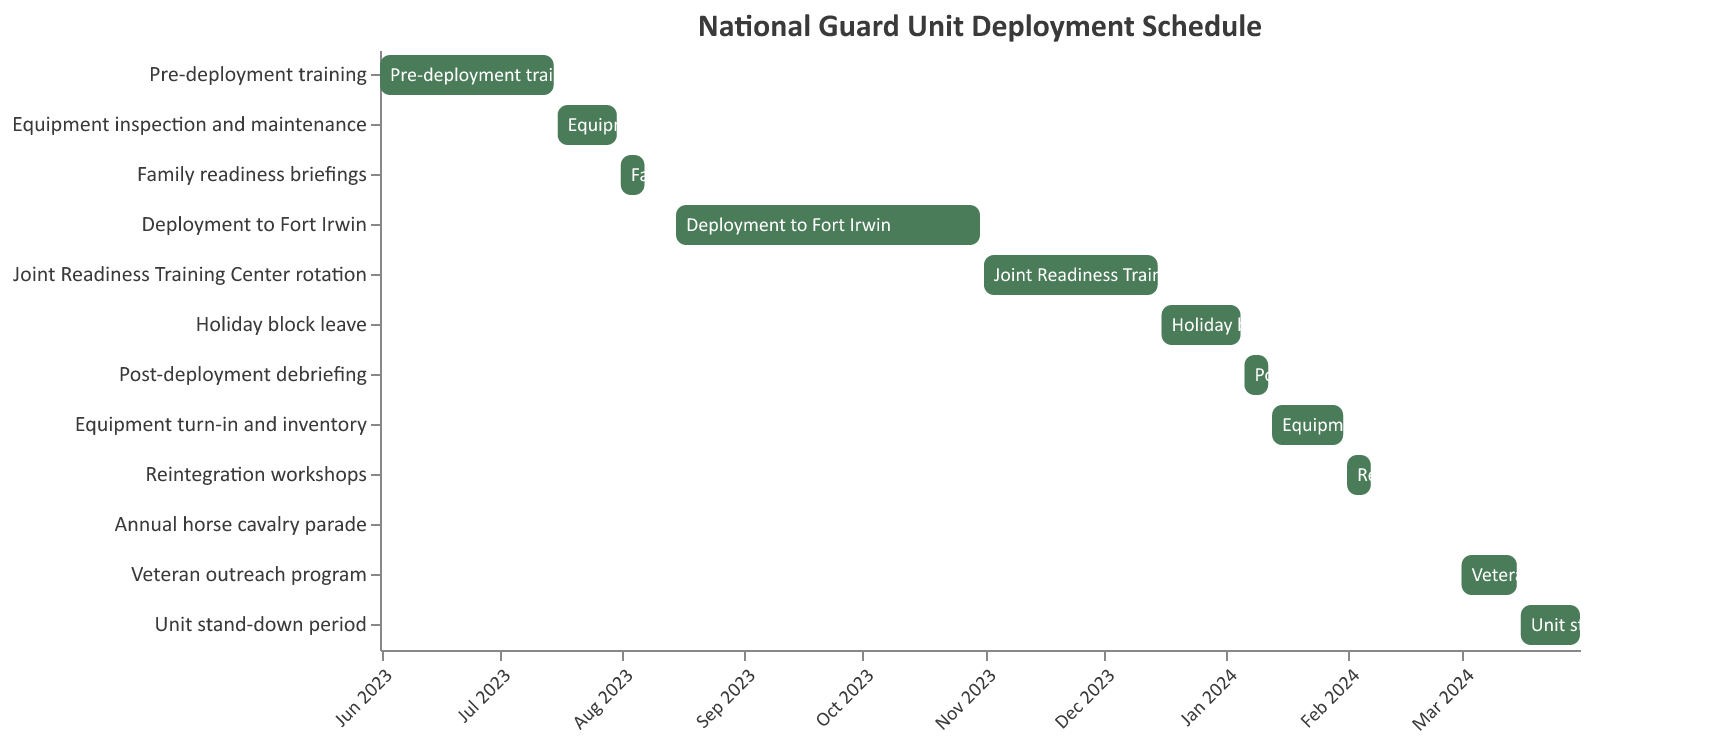What task has the longest duration in the deployment schedule? Look for the task that spans the greatest length of time on the Gantt chart. "Deployment to Fort Irwin" runs from August 15, 2023, to October 31, 2023, making it the longest task.
Answer: Deployment to Fort Irwin Which task immediately follows "Pre-deployment training"? Identify the task that starts right after the end date of "Pre-deployment training." "Equipment inspection and maintenance" starts on July 16, 2023, which is immediately after "Pre-deployment training" ends on July 15, 2023.
Answer: Equipment inspection and maintenance How many tasks are scheduled in 2023? Count the tasks that have at least part of their duration within the year 2023. This includes all tasks up to "Holiday block leave," which begins in December 2023. There are 5 such tasks.
Answer: 5 What is the duration of the "Holiday block leave"? Find the start and end date for "Holiday block leave" and calculate the difference. It starts on December 16, 2023, and ends on January 5, 2024. The duration is 21 days.
Answer: 21 days Which task has the shortest duration? Look for the task with the smallest difference between the start and end dates. "Annual horse cavalry parade" is scheduled for only one day, February 15, 2024.
Answer: Annual horse cavalry parade How long is the "Post-deployment debriefing" period? Check the start and end dates for "Post-deployment debriefing." It starts on January 6, 2024, and ends on January 12, 2024, which is a 7-day period.
Answer: 7 days Which tasks overlap with the "Deployment to Fort Irwin" task? Find tasks whose duration overlaps with "Deployment to Fort Irwin," which runs from August 15 to October 31, 2023. None of the tasks directly overlap with this period.
Answer: None How many tasks are scheduled after January 1, 2024? Count the tasks whose duration starts on or after January 1, 2024. There are 7 tasks starting with "Post-deployment debriefing."
Answer: 7 Which task starts right after "Equipment turn-in and inventory"? Look for the task that begins immediately after "Equipment turn-in and inventory," which ends on January 31, 2024. "Reintegration workshops" starts right after, on February 1, 2024.
Answer: Reintegration workshops 